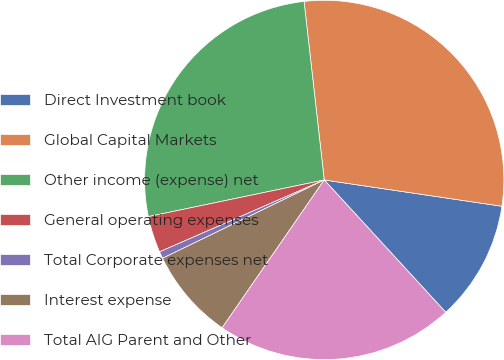<chart> <loc_0><loc_0><loc_500><loc_500><pie_chart><fcel>Direct Investment book<fcel>Global Capital Markets<fcel>Other income (expense) net<fcel>General operating expenses<fcel>Total Corporate expenses net<fcel>Interest expense<fcel>Total AIG Parent and Other<nl><fcel>10.84%<fcel>29.13%<fcel>26.48%<fcel>3.28%<fcel>0.63%<fcel>8.2%<fcel>21.44%<nl></chart> 